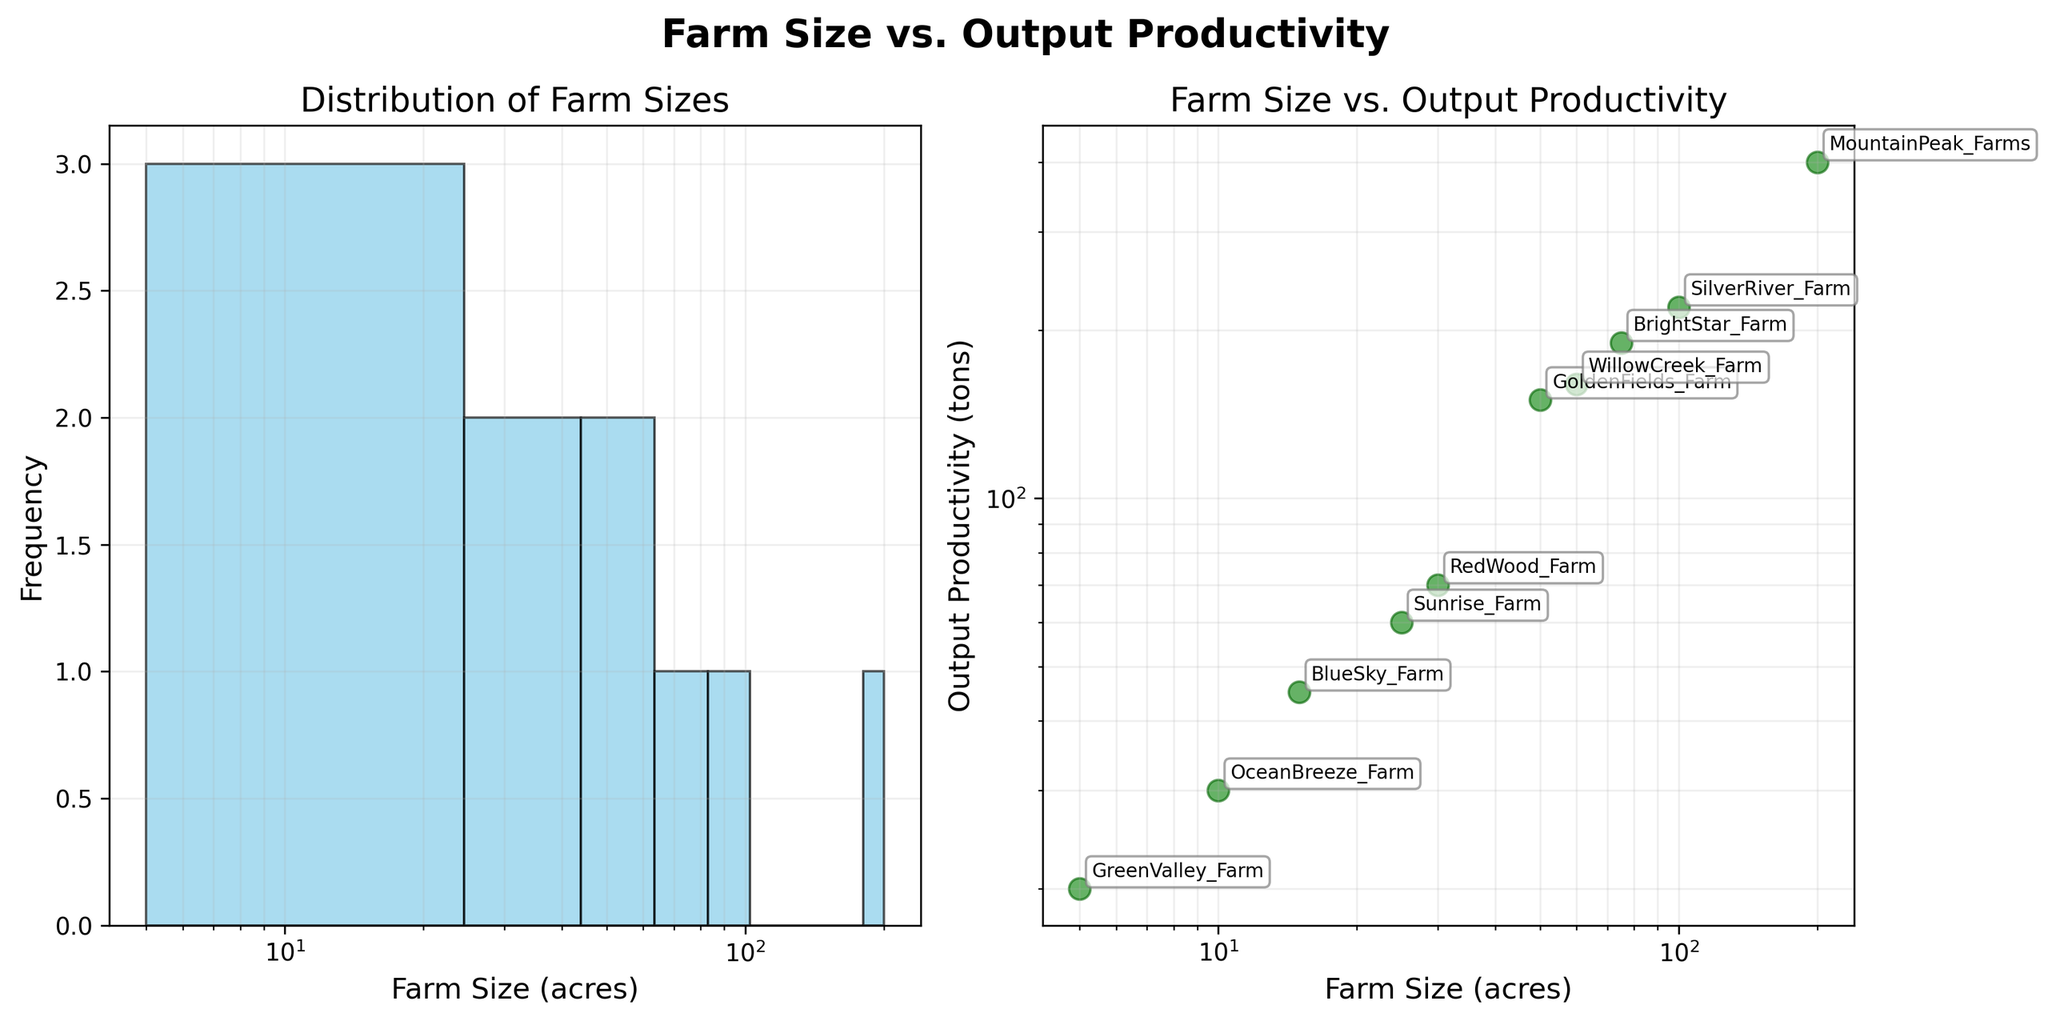what's the title of the overall figure? The title is displayed prominently at the top of the figure. It reads "Farm Size vs. Output Productivity".
Answer: Farm Size vs. Output Productivity How many farms have a size of 50 acres or less? From the histogram (subplot 1), we can count the bins with farm sizes up to 50 acres. The farms are of sizes 5, 10, 15, 25, and 50 acres, making a total of five farms.
Answer: 5 Which farm has the highest productivity? Refer to the scatter plot (subplot 2), the highest point on the y-axis signifies the highest productivity. The corresponding farm annotation is "MountainPeak_Farms".
Answer: MountainPeak_Farms Compare the output productivity of the smallest and largest farms. The smallest farm is GreenValley_Farm (5 acres, 20 tons) and the largest farm is MountainPeak_Farms (200 acres, 400 tons). The difference in output productivity is 380 tons (400 - 20).
Answer: 380 tons What is the relationship seen between farm size and output productivity? By examining subplot 2, which uses log-log scales, we see a positive correlation between farm size and productivity, as larger farms generally have higher output.
Answer: Positive correlation How many farm sizes are between 10 and 50 acres? From the histogram (subplot 1), count the bins between 10 and 50 acres. The farms are of sizes 15, 25, 30, and 50 acres, so there are four farms in this range.
Answer: 4 What is the average output productivity of farms smaller than 30 acres? Farms smaller than 30 acres are GreenValley_Farm (20 tons), BlueSky_Farm (45 tons), OceanBreeze_Farm (30 tons), and Sunrise_Farm (60 tons). The average is calculated as (20 + 45 + 30 + 60)/4 = 38.75 tons.
Answer: 38.75 tons Which farm has a size of 10 acres and how productive is it? From the scatter plot (subplot 2), OceanBreeze_Farm is annotated at 10 acres. Its productivity is 30 tons.
Answer: OceanBreeze_Farm, 30 tons Are there more farms larger than 100 acres or smaller than 10 acres? From the histogram (subplot 1), only one farm is larger than 100 acres (MountainPeak_Farms) and one farm is smaller than 10 acres (GreenValley_Farm). Hence, the numbers are equal.
Answer: Equal 